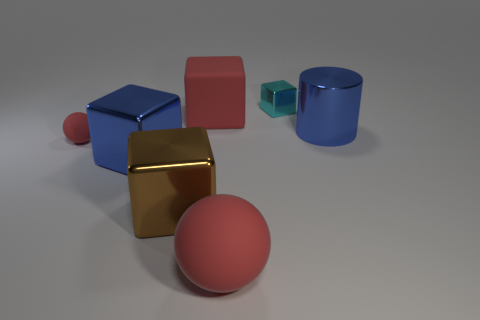What color is the matte thing that is in front of the red ball that is behind the thing that is in front of the brown block?
Give a very brief answer. Red. There is a metal cube behind the tiny red rubber ball; is it the same color as the big matte thing that is in front of the tiny matte thing?
Your answer should be very brief. No. Are there any other things that have the same color as the large sphere?
Your answer should be very brief. Yes. Are there fewer big red rubber things on the right side of the large ball than matte cylinders?
Your answer should be compact. No. How many large matte objects are there?
Provide a short and direct response. 2. Is the shape of the tiny cyan metal thing the same as the large red object right of the large red matte cube?
Provide a short and direct response. No. Are there fewer large blue metal blocks in front of the tiny cyan thing than red blocks that are behind the large red matte cube?
Offer a terse response. No. Do the small metal thing and the brown metallic object have the same shape?
Give a very brief answer. Yes. The cyan thing is what size?
Your answer should be very brief. Small. The rubber thing that is both in front of the large rubber cube and to the right of the small matte object is what color?
Keep it short and to the point. Red. 